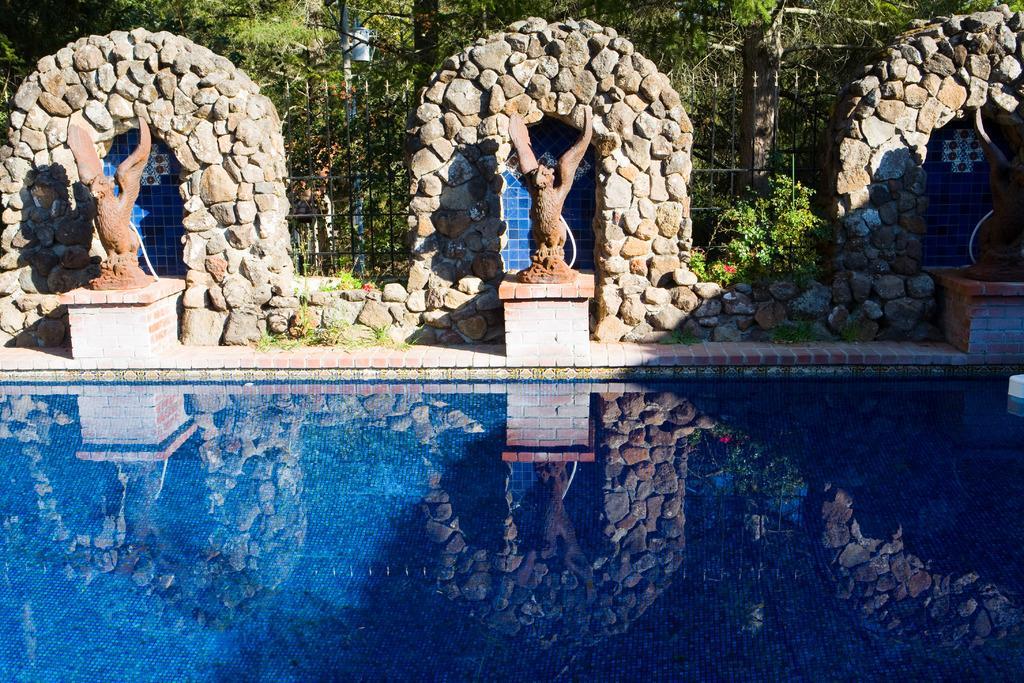Please provide a concise description of this image. In front of the image there is a swimming pool, behind the pool there are sculptures, behind that there are rock arches, metal rod fence, plants and trees. 